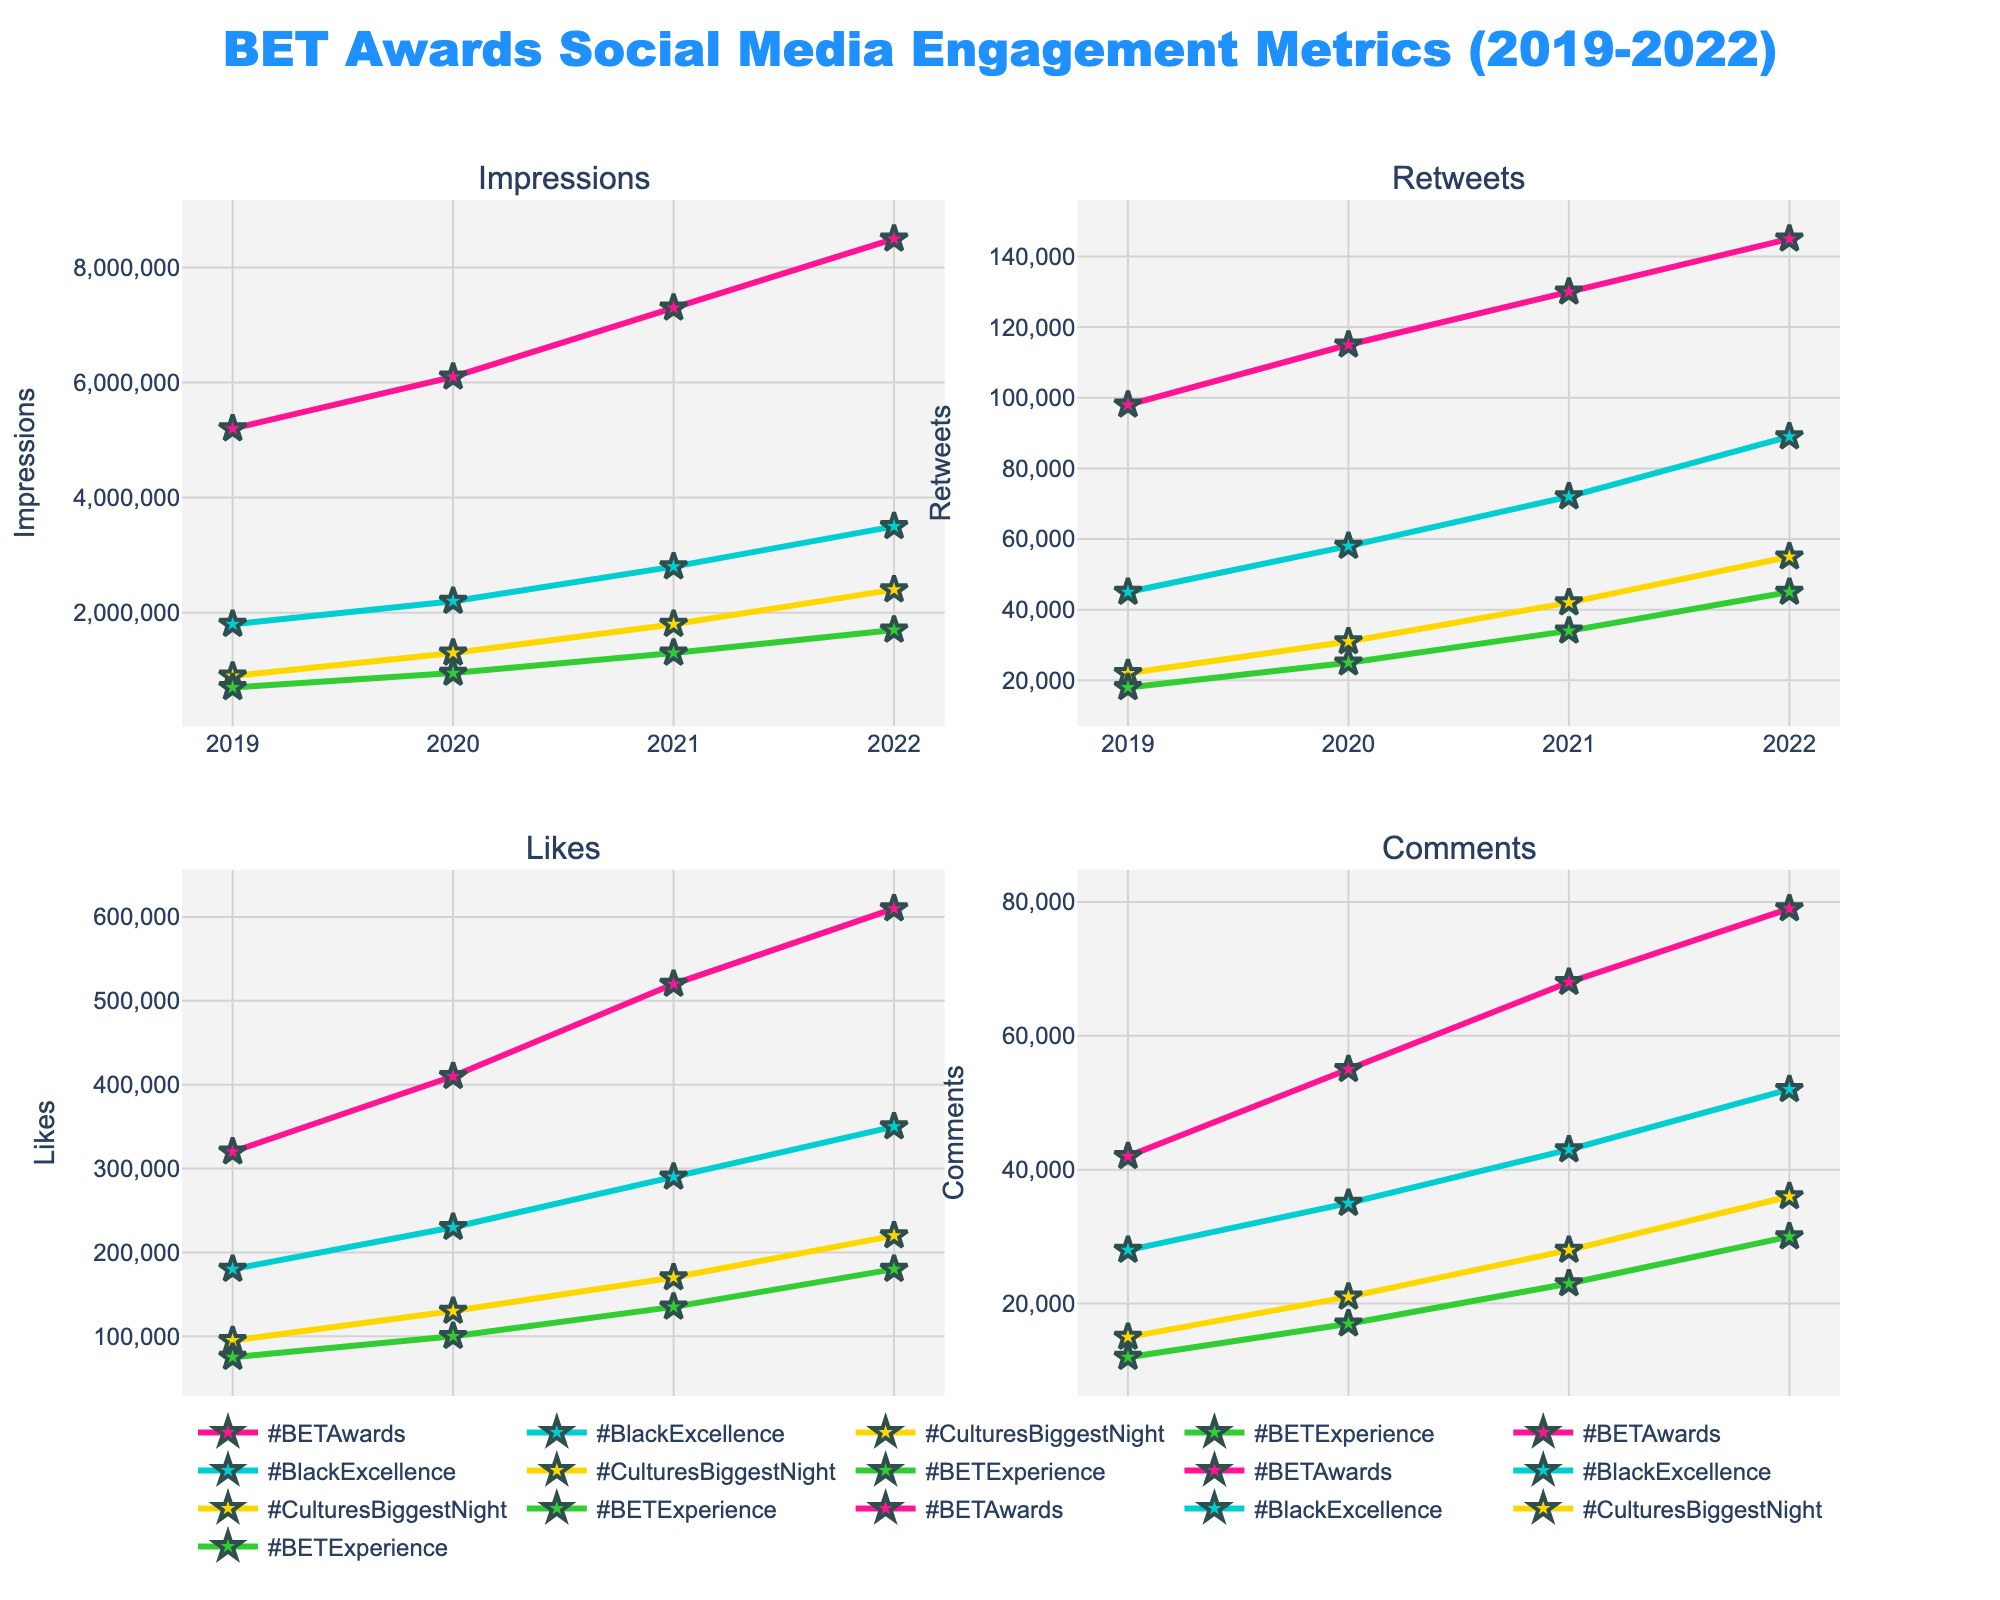which hashtag has the highest increase in impressions between 2019 and 2022? To determine the highest increase in impressions between 2019 and 2022, subtract the 2019 impressions from the 2022 impressions for each hashtag. The increases are as follows: #BETAwards: 8,500,000 - 5,200,000 = 3,300,000, #BlackExcellence: 3,500,000 - 1,800,000 = 1,700,000, #CulturesBiggestNight: 2,400,000 - 900,000 = 1,500,000, #BETExperience: 1,700,000 - 700,000 = 1,000,000. Therefore, #BETAwards has the highest increase.
Answer: #BETAwards How do the retweets of #BETAwards in 2022 compare to #BlackExcellence in 2020? Look at the values for retweets of #BETAwards in 2022 and #BlackExcellence in 2020: Retweets in 2022 for #BETAwards = 145,000, Retweets in 2020 for #BlackExcellence = 58,000. Therefore, #BETAwards in 2022 has significantly more retweets compared to #BlackExcellence in 2020.
Answer: #BETAwards has significantly more 